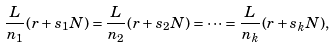Convert formula to latex. <formula><loc_0><loc_0><loc_500><loc_500>\frac { L } { n _ { 1 } } ( r + s _ { 1 } N ) = \frac { L } { n _ { 2 } } ( r + s _ { 2 } N ) = \cdots = \frac { L } { n _ { k } } ( r + s _ { k } N ) ,</formula> 